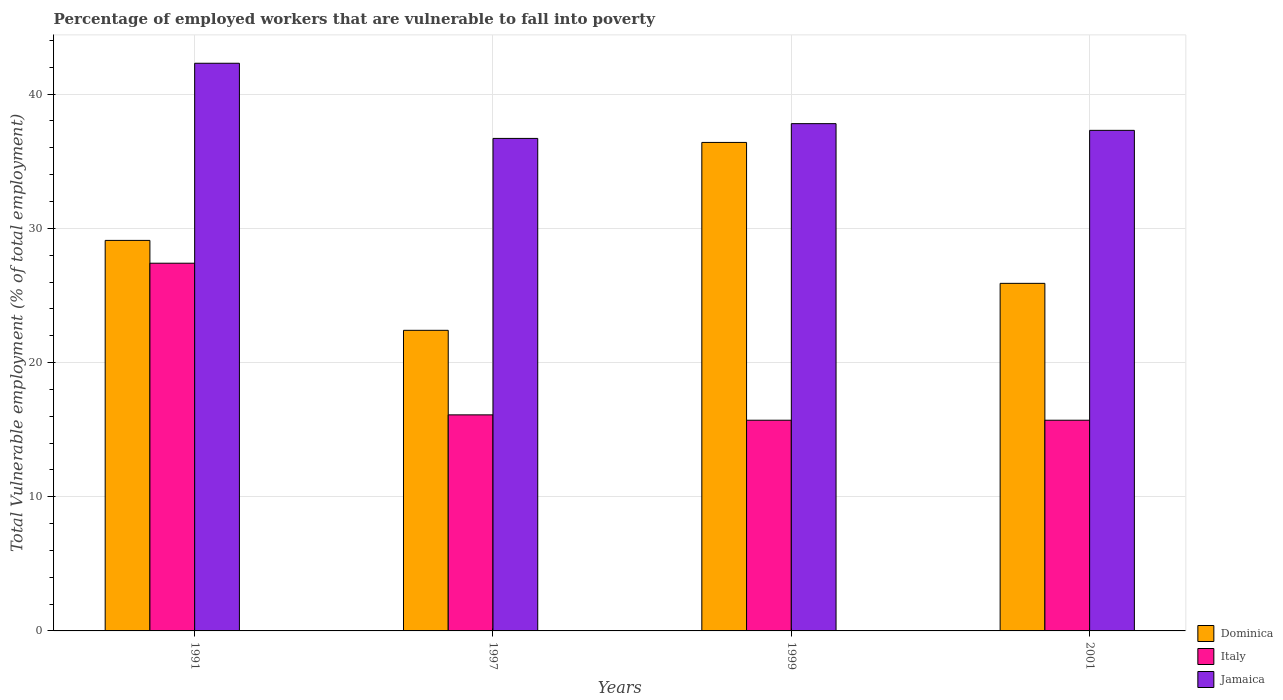How many different coloured bars are there?
Give a very brief answer. 3. How many groups of bars are there?
Provide a short and direct response. 4. Are the number of bars per tick equal to the number of legend labels?
Your answer should be compact. Yes. Are the number of bars on each tick of the X-axis equal?
Your answer should be very brief. Yes. How many bars are there on the 1st tick from the right?
Provide a succinct answer. 3. What is the label of the 3rd group of bars from the left?
Keep it short and to the point. 1999. In how many cases, is the number of bars for a given year not equal to the number of legend labels?
Keep it short and to the point. 0. What is the percentage of employed workers who are vulnerable to fall into poverty in Jamaica in 1991?
Your response must be concise. 42.3. Across all years, what is the maximum percentage of employed workers who are vulnerable to fall into poverty in Italy?
Your answer should be compact. 27.4. Across all years, what is the minimum percentage of employed workers who are vulnerable to fall into poverty in Dominica?
Provide a succinct answer. 22.4. What is the total percentage of employed workers who are vulnerable to fall into poverty in Italy in the graph?
Offer a terse response. 74.9. What is the difference between the percentage of employed workers who are vulnerable to fall into poverty in Dominica in 1991 and that in 2001?
Provide a short and direct response. 3.2. What is the difference between the percentage of employed workers who are vulnerable to fall into poverty in Italy in 2001 and the percentage of employed workers who are vulnerable to fall into poverty in Jamaica in 1999?
Make the answer very short. -22.1. What is the average percentage of employed workers who are vulnerable to fall into poverty in Jamaica per year?
Make the answer very short. 38.52. In the year 2001, what is the difference between the percentage of employed workers who are vulnerable to fall into poverty in Jamaica and percentage of employed workers who are vulnerable to fall into poverty in Dominica?
Keep it short and to the point. 11.4. What is the ratio of the percentage of employed workers who are vulnerable to fall into poverty in Dominica in 1991 to that in 1999?
Offer a terse response. 0.8. What is the difference between the highest and the second highest percentage of employed workers who are vulnerable to fall into poverty in Jamaica?
Your response must be concise. 4.5. What is the difference between the highest and the lowest percentage of employed workers who are vulnerable to fall into poverty in Dominica?
Your response must be concise. 14. Is the sum of the percentage of employed workers who are vulnerable to fall into poverty in Italy in 1991 and 1997 greater than the maximum percentage of employed workers who are vulnerable to fall into poverty in Jamaica across all years?
Offer a terse response. Yes. What does the 2nd bar from the left in 1997 represents?
Offer a very short reply. Italy. What does the 3rd bar from the right in 2001 represents?
Provide a succinct answer. Dominica. Are all the bars in the graph horizontal?
Give a very brief answer. No. What is the difference between two consecutive major ticks on the Y-axis?
Offer a terse response. 10. Are the values on the major ticks of Y-axis written in scientific E-notation?
Make the answer very short. No. Does the graph contain any zero values?
Ensure brevity in your answer.  No. What is the title of the graph?
Give a very brief answer. Percentage of employed workers that are vulnerable to fall into poverty. What is the label or title of the Y-axis?
Your response must be concise. Total Vulnerable employment (% of total employment). What is the Total Vulnerable employment (% of total employment) of Dominica in 1991?
Your answer should be compact. 29.1. What is the Total Vulnerable employment (% of total employment) of Italy in 1991?
Provide a short and direct response. 27.4. What is the Total Vulnerable employment (% of total employment) in Jamaica in 1991?
Your answer should be very brief. 42.3. What is the Total Vulnerable employment (% of total employment) in Dominica in 1997?
Ensure brevity in your answer.  22.4. What is the Total Vulnerable employment (% of total employment) in Italy in 1997?
Your response must be concise. 16.1. What is the Total Vulnerable employment (% of total employment) in Jamaica in 1997?
Make the answer very short. 36.7. What is the Total Vulnerable employment (% of total employment) in Dominica in 1999?
Offer a very short reply. 36.4. What is the Total Vulnerable employment (% of total employment) in Italy in 1999?
Make the answer very short. 15.7. What is the Total Vulnerable employment (% of total employment) of Jamaica in 1999?
Your response must be concise. 37.8. What is the Total Vulnerable employment (% of total employment) in Dominica in 2001?
Provide a succinct answer. 25.9. What is the Total Vulnerable employment (% of total employment) of Italy in 2001?
Offer a very short reply. 15.7. What is the Total Vulnerable employment (% of total employment) in Jamaica in 2001?
Offer a terse response. 37.3. Across all years, what is the maximum Total Vulnerable employment (% of total employment) of Dominica?
Offer a terse response. 36.4. Across all years, what is the maximum Total Vulnerable employment (% of total employment) of Italy?
Keep it short and to the point. 27.4. Across all years, what is the maximum Total Vulnerable employment (% of total employment) in Jamaica?
Your response must be concise. 42.3. Across all years, what is the minimum Total Vulnerable employment (% of total employment) of Dominica?
Your response must be concise. 22.4. Across all years, what is the minimum Total Vulnerable employment (% of total employment) of Italy?
Your answer should be compact. 15.7. Across all years, what is the minimum Total Vulnerable employment (% of total employment) in Jamaica?
Ensure brevity in your answer.  36.7. What is the total Total Vulnerable employment (% of total employment) of Dominica in the graph?
Offer a terse response. 113.8. What is the total Total Vulnerable employment (% of total employment) in Italy in the graph?
Your response must be concise. 74.9. What is the total Total Vulnerable employment (% of total employment) in Jamaica in the graph?
Your answer should be compact. 154.1. What is the difference between the Total Vulnerable employment (% of total employment) in Jamaica in 1991 and that in 1999?
Give a very brief answer. 4.5. What is the difference between the Total Vulnerable employment (% of total employment) in Dominica in 1997 and that in 2001?
Ensure brevity in your answer.  -3.5. What is the difference between the Total Vulnerable employment (% of total employment) in Italy in 1997 and that in 2001?
Your response must be concise. 0.4. What is the difference between the Total Vulnerable employment (% of total employment) of Jamaica in 1997 and that in 2001?
Your answer should be compact. -0.6. What is the difference between the Total Vulnerable employment (% of total employment) in Dominica in 1999 and that in 2001?
Ensure brevity in your answer.  10.5. What is the difference between the Total Vulnerable employment (% of total employment) of Dominica in 1991 and the Total Vulnerable employment (% of total employment) of Jamaica in 1997?
Provide a succinct answer. -7.6. What is the difference between the Total Vulnerable employment (% of total employment) of Italy in 1991 and the Total Vulnerable employment (% of total employment) of Jamaica in 1997?
Make the answer very short. -9.3. What is the difference between the Total Vulnerable employment (% of total employment) in Dominica in 1991 and the Total Vulnerable employment (% of total employment) in Italy in 1999?
Offer a very short reply. 13.4. What is the difference between the Total Vulnerable employment (% of total employment) in Dominica in 1991 and the Total Vulnerable employment (% of total employment) in Jamaica in 1999?
Make the answer very short. -8.7. What is the difference between the Total Vulnerable employment (% of total employment) of Dominica in 1991 and the Total Vulnerable employment (% of total employment) of Italy in 2001?
Your response must be concise. 13.4. What is the difference between the Total Vulnerable employment (% of total employment) of Dominica in 1991 and the Total Vulnerable employment (% of total employment) of Jamaica in 2001?
Keep it short and to the point. -8.2. What is the difference between the Total Vulnerable employment (% of total employment) of Dominica in 1997 and the Total Vulnerable employment (% of total employment) of Jamaica in 1999?
Your response must be concise. -15.4. What is the difference between the Total Vulnerable employment (% of total employment) in Italy in 1997 and the Total Vulnerable employment (% of total employment) in Jamaica in 1999?
Your answer should be compact. -21.7. What is the difference between the Total Vulnerable employment (% of total employment) in Dominica in 1997 and the Total Vulnerable employment (% of total employment) in Jamaica in 2001?
Provide a short and direct response. -14.9. What is the difference between the Total Vulnerable employment (% of total employment) of Italy in 1997 and the Total Vulnerable employment (% of total employment) of Jamaica in 2001?
Provide a succinct answer. -21.2. What is the difference between the Total Vulnerable employment (% of total employment) of Dominica in 1999 and the Total Vulnerable employment (% of total employment) of Italy in 2001?
Your answer should be very brief. 20.7. What is the difference between the Total Vulnerable employment (% of total employment) in Dominica in 1999 and the Total Vulnerable employment (% of total employment) in Jamaica in 2001?
Give a very brief answer. -0.9. What is the difference between the Total Vulnerable employment (% of total employment) of Italy in 1999 and the Total Vulnerable employment (% of total employment) of Jamaica in 2001?
Provide a short and direct response. -21.6. What is the average Total Vulnerable employment (% of total employment) of Dominica per year?
Offer a terse response. 28.45. What is the average Total Vulnerable employment (% of total employment) of Italy per year?
Offer a terse response. 18.73. What is the average Total Vulnerable employment (% of total employment) of Jamaica per year?
Make the answer very short. 38.52. In the year 1991, what is the difference between the Total Vulnerable employment (% of total employment) in Dominica and Total Vulnerable employment (% of total employment) in Italy?
Your response must be concise. 1.7. In the year 1991, what is the difference between the Total Vulnerable employment (% of total employment) of Italy and Total Vulnerable employment (% of total employment) of Jamaica?
Give a very brief answer. -14.9. In the year 1997, what is the difference between the Total Vulnerable employment (% of total employment) of Dominica and Total Vulnerable employment (% of total employment) of Jamaica?
Your answer should be very brief. -14.3. In the year 1997, what is the difference between the Total Vulnerable employment (% of total employment) in Italy and Total Vulnerable employment (% of total employment) in Jamaica?
Your answer should be very brief. -20.6. In the year 1999, what is the difference between the Total Vulnerable employment (% of total employment) of Dominica and Total Vulnerable employment (% of total employment) of Italy?
Your answer should be compact. 20.7. In the year 1999, what is the difference between the Total Vulnerable employment (% of total employment) of Italy and Total Vulnerable employment (% of total employment) of Jamaica?
Keep it short and to the point. -22.1. In the year 2001, what is the difference between the Total Vulnerable employment (% of total employment) in Italy and Total Vulnerable employment (% of total employment) in Jamaica?
Give a very brief answer. -21.6. What is the ratio of the Total Vulnerable employment (% of total employment) of Dominica in 1991 to that in 1997?
Your answer should be very brief. 1.3. What is the ratio of the Total Vulnerable employment (% of total employment) in Italy in 1991 to that in 1997?
Give a very brief answer. 1.7. What is the ratio of the Total Vulnerable employment (% of total employment) in Jamaica in 1991 to that in 1997?
Your response must be concise. 1.15. What is the ratio of the Total Vulnerable employment (% of total employment) of Dominica in 1991 to that in 1999?
Ensure brevity in your answer.  0.8. What is the ratio of the Total Vulnerable employment (% of total employment) in Italy in 1991 to that in 1999?
Ensure brevity in your answer.  1.75. What is the ratio of the Total Vulnerable employment (% of total employment) of Jamaica in 1991 to that in 1999?
Your response must be concise. 1.12. What is the ratio of the Total Vulnerable employment (% of total employment) of Dominica in 1991 to that in 2001?
Ensure brevity in your answer.  1.12. What is the ratio of the Total Vulnerable employment (% of total employment) in Italy in 1991 to that in 2001?
Keep it short and to the point. 1.75. What is the ratio of the Total Vulnerable employment (% of total employment) of Jamaica in 1991 to that in 2001?
Your response must be concise. 1.13. What is the ratio of the Total Vulnerable employment (% of total employment) of Dominica in 1997 to that in 1999?
Your answer should be compact. 0.62. What is the ratio of the Total Vulnerable employment (% of total employment) of Italy in 1997 to that in 1999?
Give a very brief answer. 1.03. What is the ratio of the Total Vulnerable employment (% of total employment) of Jamaica in 1997 to that in 1999?
Provide a succinct answer. 0.97. What is the ratio of the Total Vulnerable employment (% of total employment) in Dominica in 1997 to that in 2001?
Your answer should be very brief. 0.86. What is the ratio of the Total Vulnerable employment (% of total employment) of Italy in 1997 to that in 2001?
Make the answer very short. 1.03. What is the ratio of the Total Vulnerable employment (% of total employment) of Jamaica in 1997 to that in 2001?
Give a very brief answer. 0.98. What is the ratio of the Total Vulnerable employment (% of total employment) of Dominica in 1999 to that in 2001?
Make the answer very short. 1.41. What is the ratio of the Total Vulnerable employment (% of total employment) in Italy in 1999 to that in 2001?
Provide a succinct answer. 1. What is the ratio of the Total Vulnerable employment (% of total employment) of Jamaica in 1999 to that in 2001?
Your response must be concise. 1.01. What is the difference between the highest and the second highest Total Vulnerable employment (% of total employment) in Dominica?
Your answer should be compact. 7.3. What is the difference between the highest and the second highest Total Vulnerable employment (% of total employment) in Italy?
Your answer should be compact. 11.3. What is the difference between the highest and the second highest Total Vulnerable employment (% of total employment) in Jamaica?
Provide a succinct answer. 4.5. What is the difference between the highest and the lowest Total Vulnerable employment (% of total employment) in Dominica?
Provide a short and direct response. 14. 